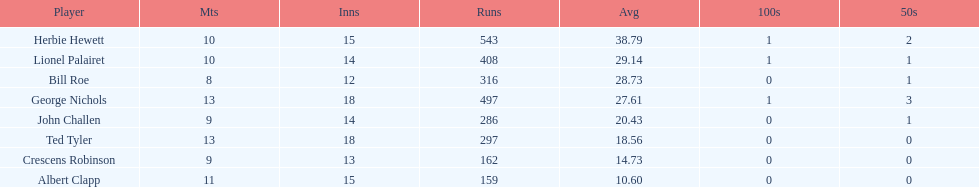Which player had an average of more than 25? Herbie Hewett. 